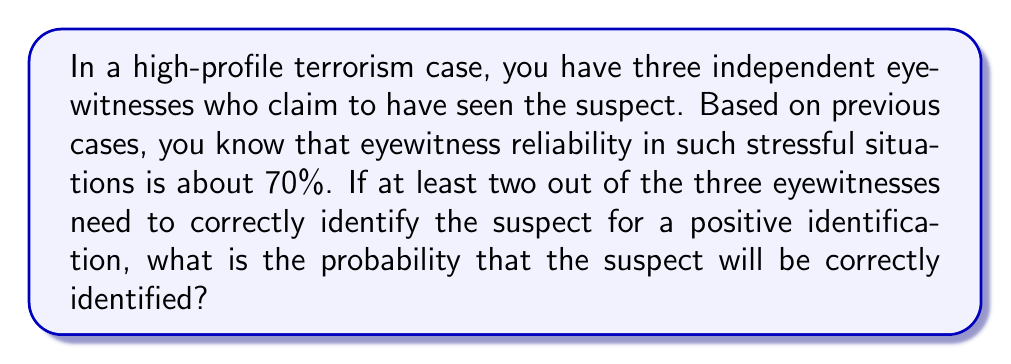Give your solution to this math problem. Let's approach this step-by-step:

1) First, we need to understand what constitutes a correct identification. We need at least 2 out of 3 witnesses to correctly identify the suspect.

2) The probability of each witness correctly identifying the suspect is 0.7 (70%).

3) We can use the binomial probability formula to solve this problem. We need to calculate the probability of exactly 2 correct identifications plus the probability of exactly 3 correct identifications.

4) The probability of exactly k successes in n trials is given by the formula:

   $$P(X = k) = \binom{n}{k} p^k (1-p)^{n-k}$$

   Where $n$ is the number of trials, $k$ is the number of successes, $p$ is the probability of success on each trial.

5) For 2 correct identifications:
   $$P(X = 2) = \binom{3}{2} (0.7)^2 (0.3)^1 = 3 \cdot 0.49 \cdot 0.3 = 0.441$$

6) For 3 correct identifications:
   $$P(X = 3) = \binom{3}{3} (0.7)^3 (0.3)^0 = 1 \cdot 0.343 \cdot 1 = 0.343$$

7) The total probability is the sum of these two probabilities:
   $$P(\text{correct identification}) = 0.441 + 0.343 = 0.784$$

Therefore, the probability of correctly identifying the suspect is 0.784 or 78.4%.
Answer: 0.784 